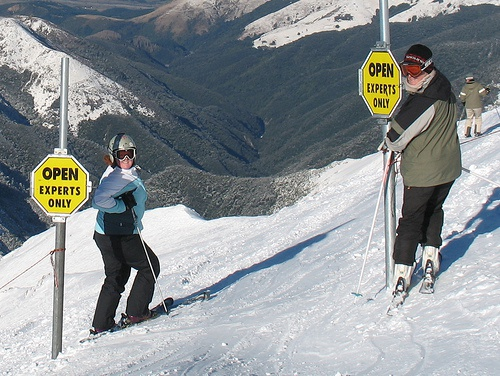Describe the objects in this image and their specific colors. I can see people in gray, black, lightgray, and darkgray tones, people in gray, black, and white tones, people in gray and darkgray tones, skis in gray, black, darkblue, and darkgray tones, and skis in gray, lightgray, and darkgray tones in this image. 